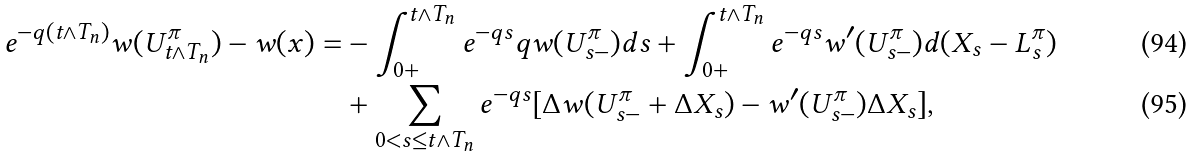<formula> <loc_0><loc_0><loc_500><loc_500>e ^ { - q ( t \wedge T _ { n } ) } w ( { U } ^ { \pi } _ { t \wedge T _ { n } } ) - w ( x ) = & - \int _ { 0 + } ^ { t \wedge T _ { n } } e ^ { - q s } q w ( { U } ^ { \pi } _ { s - } ) d s + \int _ { 0 + } ^ { t \wedge T _ { n } } e ^ { - q s } w ^ { \prime } ( { U } ^ { \pi } _ { s - } ) d ( X _ { s } - { L } ^ { \pi } _ { s } ) \\ & + \sum _ { 0 < s \leq t \wedge T _ { n } } e ^ { - q s } [ \Delta w ( { U } ^ { \pi } _ { s - } + \Delta X _ { s } ) - w ^ { \prime } ( { U } ^ { \pi } _ { s - } ) \Delta X _ { s } ] ,</formula> 